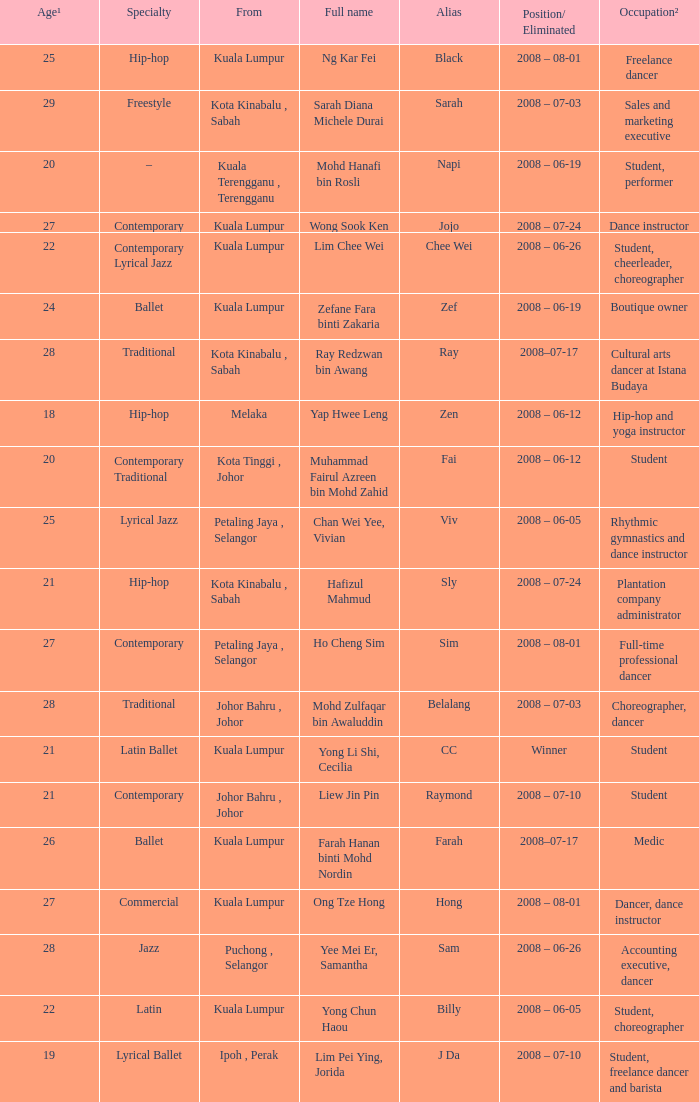What is Position/ Eliminated, when From is "Kuala Lumpur", and when Specialty is "Contemporary Lyrical Jazz"? 2008 – 06-26. 